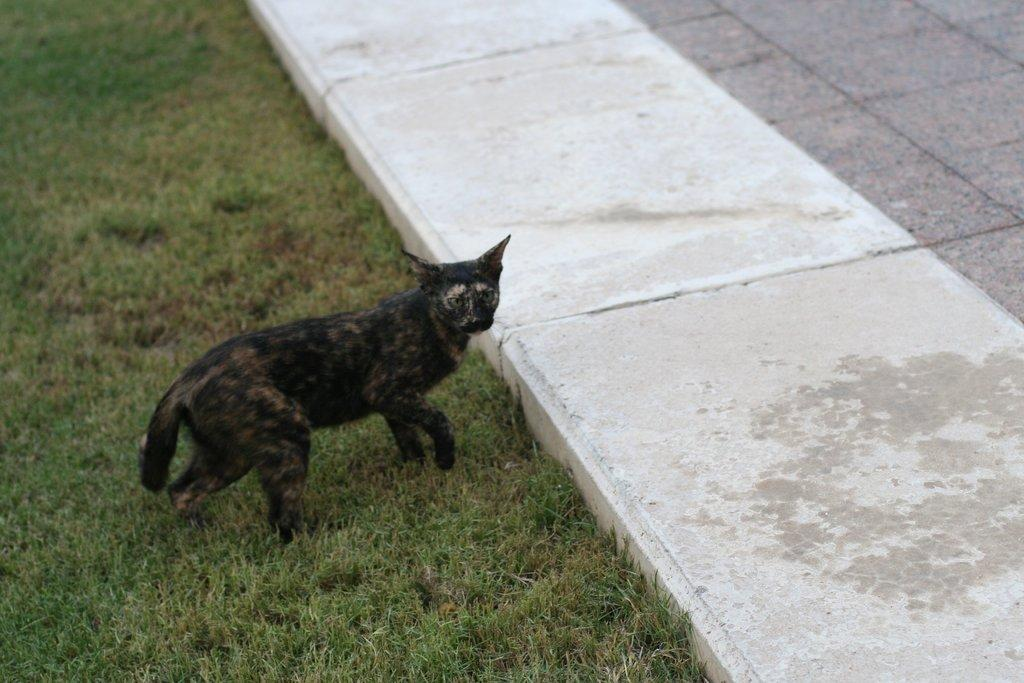What type of vegetation is on the left side of the image? There is grass on the left side of the image. What animal can be seen standing on the grass? A black-colored cat is standing on the grass. What is the surface on the right side of the image? There is a footpath on the right side of the image. What type of account does the cat have in the image? There is no mention of an account in the image, and the cat is not a human who could have an account. Can you see any nuts in the image? There is no mention of nuts in the image. 